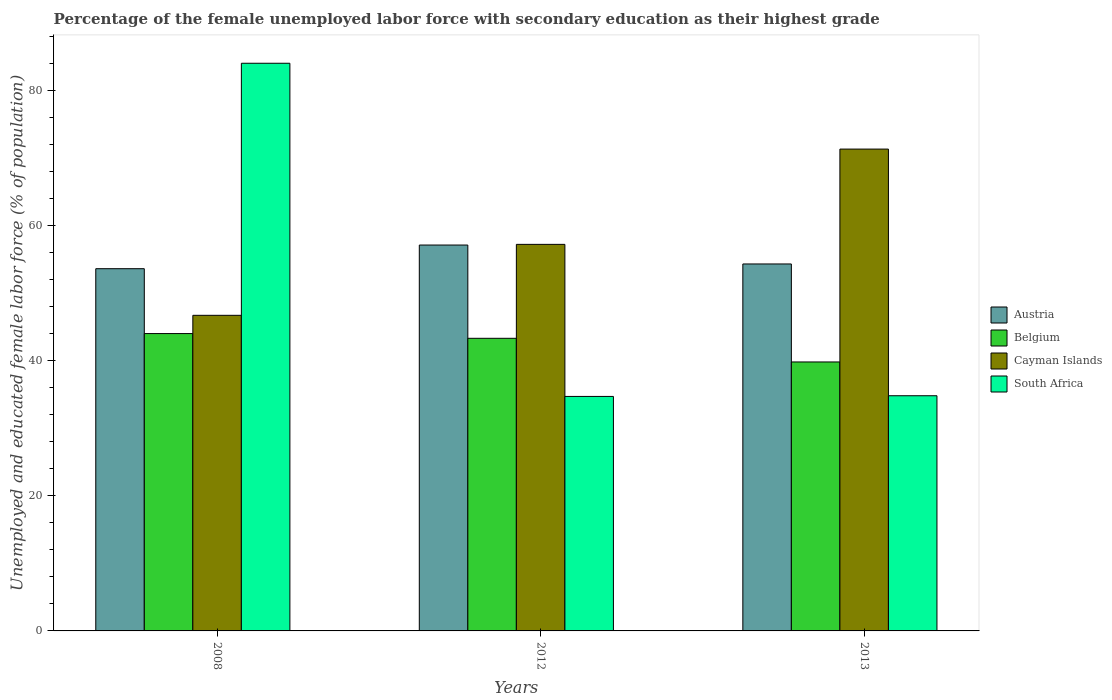How many different coloured bars are there?
Provide a short and direct response. 4. Are the number of bars per tick equal to the number of legend labels?
Provide a succinct answer. Yes. Are the number of bars on each tick of the X-axis equal?
Your answer should be very brief. Yes. How many bars are there on the 1st tick from the left?
Keep it short and to the point. 4. How many bars are there on the 3rd tick from the right?
Provide a short and direct response. 4. What is the label of the 3rd group of bars from the left?
Make the answer very short. 2013. What is the percentage of the unemployed female labor force with secondary education in Austria in 2008?
Offer a very short reply. 53.6. Across all years, what is the maximum percentage of the unemployed female labor force with secondary education in Austria?
Your response must be concise. 57.1. Across all years, what is the minimum percentage of the unemployed female labor force with secondary education in South Africa?
Keep it short and to the point. 34.7. In which year was the percentage of the unemployed female labor force with secondary education in Cayman Islands maximum?
Your answer should be compact. 2013. In which year was the percentage of the unemployed female labor force with secondary education in Austria minimum?
Ensure brevity in your answer.  2008. What is the total percentage of the unemployed female labor force with secondary education in Belgium in the graph?
Offer a terse response. 127.1. What is the difference between the percentage of the unemployed female labor force with secondary education in Austria in 2008 and that in 2013?
Your answer should be compact. -0.7. What is the difference between the percentage of the unemployed female labor force with secondary education in South Africa in 2012 and the percentage of the unemployed female labor force with secondary education in Cayman Islands in 2013?
Provide a short and direct response. -36.6. What is the average percentage of the unemployed female labor force with secondary education in Belgium per year?
Make the answer very short. 42.37. In the year 2008, what is the difference between the percentage of the unemployed female labor force with secondary education in Cayman Islands and percentage of the unemployed female labor force with secondary education in South Africa?
Give a very brief answer. -37.3. What is the ratio of the percentage of the unemployed female labor force with secondary education in South Africa in 2012 to that in 2013?
Keep it short and to the point. 1. What is the difference between the highest and the second highest percentage of the unemployed female labor force with secondary education in Austria?
Offer a terse response. 2.8. What is the difference between the highest and the lowest percentage of the unemployed female labor force with secondary education in Cayman Islands?
Provide a short and direct response. 24.6. What does the 2nd bar from the left in 2012 represents?
Offer a very short reply. Belgium. Is it the case that in every year, the sum of the percentage of the unemployed female labor force with secondary education in Belgium and percentage of the unemployed female labor force with secondary education in Cayman Islands is greater than the percentage of the unemployed female labor force with secondary education in South Africa?
Offer a very short reply. Yes. Are all the bars in the graph horizontal?
Your response must be concise. No. How many years are there in the graph?
Your answer should be very brief. 3. What is the difference between two consecutive major ticks on the Y-axis?
Offer a terse response. 20. Does the graph contain any zero values?
Provide a short and direct response. No. Where does the legend appear in the graph?
Offer a very short reply. Center right. How many legend labels are there?
Ensure brevity in your answer.  4. How are the legend labels stacked?
Your answer should be compact. Vertical. What is the title of the graph?
Provide a short and direct response. Percentage of the female unemployed labor force with secondary education as their highest grade. Does "Comoros" appear as one of the legend labels in the graph?
Offer a terse response. No. What is the label or title of the X-axis?
Your answer should be very brief. Years. What is the label or title of the Y-axis?
Provide a succinct answer. Unemployed and educated female labor force (% of population). What is the Unemployed and educated female labor force (% of population) in Austria in 2008?
Your answer should be very brief. 53.6. What is the Unemployed and educated female labor force (% of population) of Cayman Islands in 2008?
Offer a very short reply. 46.7. What is the Unemployed and educated female labor force (% of population) of South Africa in 2008?
Your answer should be very brief. 84. What is the Unemployed and educated female labor force (% of population) in Austria in 2012?
Keep it short and to the point. 57.1. What is the Unemployed and educated female labor force (% of population) of Belgium in 2012?
Ensure brevity in your answer.  43.3. What is the Unemployed and educated female labor force (% of population) in Cayman Islands in 2012?
Provide a short and direct response. 57.2. What is the Unemployed and educated female labor force (% of population) in South Africa in 2012?
Your answer should be compact. 34.7. What is the Unemployed and educated female labor force (% of population) of Austria in 2013?
Make the answer very short. 54.3. What is the Unemployed and educated female labor force (% of population) in Belgium in 2013?
Provide a succinct answer. 39.8. What is the Unemployed and educated female labor force (% of population) of Cayman Islands in 2013?
Provide a short and direct response. 71.3. What is the Unemployed and educated female labor force (% of population) of South Africa in 2013?
Your answer should be compact. 34.8. Across all years, what is the maximum Unemployed and educated female labor force (% of population) of Austria?
Provide a short and direct response. 57.1. Across all years, what is the maximum Unemployed and educated female labor force (% of population) in Cayman Islands?
Provide a short and direct response. 71.3. Across all years, what is the maximum Unemployed and educated female labor force (% of population) of South Africa?
Offer a terse response. 84. Across all years, what is the minimum Unemployed and educated female labor force (% of population) of Austria?
Offer a very short reply. 53.6. Across all years, what is the minimum Unemployed and educated female labor force (% of population) of Belgium?
Your response must be concise. 39.8. Across all years, what is the minimum Unemployed and educated female labor force (% of population) of Cayman Islands?
Offer a terse response. 46.7. Across all years, what is the minimum Unemployed and educated female labor force (% of population) of South Africa?
Make the answer very short. 34.7. What is the total Unemployed and educated female labor force (% of population) in Austria in the graph?
Make the answer very short. 165. What is the total Unemployed and educated female labor force (% of population) of Belgium in the graph?
Give a very brief answer. 127.1. What is the total Unemployed and educated female labor force (% of population) of Cayman Islands in the graph?
Your answer should be compact. 175.2. What is the total Unemployed and educated female labor force (% of population) of South Africa in the graph?
Provide a succinct answer. 153.5. What is the difference between the Unemployed and educated female labor force (% of population) of Austria in 2008 and that in 2012?
Your answer should be compact. -3.5. What is the difference between the Unemployed and educated female labor force (% of population) of Cayman Islands in 2008 and that in 2012?
Provide a succinct answer. -10.5. What is the difference between the Unemployed and educated female labor force (% of population) of South Africa in 2008 and that in 2012?
Ensure brevity in your answer.  49.3. What is the difference between the Unemployed and educated female labor force (% of population) in Cayman Islands in 2008 and that in 2013?
Your answer should be very brief. -24.6. What is the difference between the Unemployed and educated female labor force (% of population) of South Africa in 2008 and that in 2013?
Keep it short and to the point. 49.2. What is the difference between the Unemployed and educated female labor force (% of population) of Austria in 2012 and that in 2013?
Provide a short and direct response. 2.8. What is the difference between the Unemployed and educated female labor force (% of population) in Cayman Islands in 2012 and that in 2013?
Your answer should be very brief. -14.1. What is the difference between the Unemployed and educated female labor force (% of population) of South Africa in 2012 and that in 2013?
Make the answer very short. -0.1. What is the difference between the Unemployed and educated female labor force (% of population) in Austria in 2008 and the Unemployed and educated female labor force (% of population) in Belgium in 2012?
Make the answer very short. 10.3. What is the difference between the Unemployed and educated female labor force (% of population) in Austria in 2008 and the Unemployed and educated female labor force (% of population) in Cayman Islands in 2012?
Make the answer very short. -3.6. What is the difference between the Unemployed and educated female labor force (% of population) of Austria in 2008 and the Unemployed and educated female labor force (% of population) of South Africa in 2012?
Provide a short and direct response. 18.9. What is the difference between the Unemployed and educated female labor force (% of population) in Belgium in 2008 and the Unemployed and educated female labor force (% of population) in South Africa in 2012?
Offer a very short reply. 9.3. What is the difference between the Unemployed and educated female labor force (% of population) in Cayman Islands in 2008 and the Unemployed and educated female labor force (% of population) in South Africa in 2012?
Make the answer very short. 12. What is the difference between the Unemployed and educated female labor force (% of population) in Austria in 2008 and the Unemployed and educated female labor force (% of population) in Cayman Islands in 2013?
Offer a terse response. -17.7. What is the difference between the Unemployed and educated female labor force (% of population) of Austria in 2008 and the Unemployed and educated female labor force (% of population) of South Africa in 2013?
Your answer should be very brief. 18.8. What is the difference between the Unemployed and educated female labor force (% of population) in Belgium in 2008 and the Unemployed and educated female labor force (% of population) in Cayman Islands in 2013?
Your answer should be very brief. -27.3. What is the difference between the Unemployed and educated female labor force (% of population) in Austria in 2012 and the Unemployed and educated female labor force (% of population) in Belgium in 2013?
Give a very brief answer. 17.3. What is the difference between the Unemployed and educated female labor force (% of population) of Austria in 2012 and the Unemployed and educated female labor force (% of population) of South Africa in 2013?
Keep it short and to the point. 22.3. What is the difference between the Unemployed and educated female labor force (% of population) of Belgium in 2012 and the Unemployed and educated female labor force (% of population) of Cayman Islands in 2013?
Make the answer very short. -28. What is the difference between the Unemployed and educated female labor force (% of population) in Cayman Islands in 2012 and the Unemployed and educated female labor force (% of population) in South Africa in 2013?
Keep it short and to the point. 22.4. What is the average Unemployed and educated female labor force (% of population) of Austria per year?
Ensure brevity in your answer.  55. What is the average Unemployed and educated female labor force (% of population) in Belgium per year?
Ensure brevity in your answer.  42.37. What is the average Unemployed and educated female labor force (% of population) in Cayman Islands per year?
Make the answer very short. 58.4. What is the average Unemployed and educated female labor force (% of population) of South Africa per year?
Keep it short and to the point. 51.17. In the year 2008, what is the difference between the Unemployed and educated female labor force (% of population) of Austria and Unemployed and educated female labor force (% of population) of Cayman Islands?
Your answer should be very brief. 6.9. In the year 2008, what is the difference between the Unemployed and educated female labor force (% of population) of Austria and Unemployed and educated female labor force (% of population) of South Africa?
Your answer should be very brief. -30.4. In the year 2008, what is the difference between the Unemployed and educated female labor force (% of population) of Belgium and Unemployed and educated female labor force (% of population) of Cayman Islands?
Your answer should be very brief. -2.7. In the year 2008, what is the difference between the Unemployed and educated female labor force (% of population) of Belgium and Unemployed and educated female labor force (% of population) of South Africa?
Offer a terse response. -40. In the year 2008, what is the difference between the Unemployed and educated female labor force (% of population) in Cayman Islands and Unemployed and educated female labor force (% of population) in South Africa?
Make the answer very short. -37.3. In the year 2012, what is the difference between the Unemployed and educated female labor force (% of population) in Austria and Unemployed and educated female labor force (% of population) in Cayman Islands?
Your response must be concise. -0.1. In the year 2012, what is the difference between the Unemployed and educated female labor force (% of population) in Austria and Unemployed and educated female labor force (% of population) in South Africa?
Offer a terse response. 22.4. In the year 2012, what is the difference between the Unemployed and educated female labor force (% of population) of Cayman Islands and Unemployed and educated female labor force (% of population) of South Africa?
Ensure brevity in your answer.  22.5. In the year 2013, what is the difference between the Unemployed and educated female labor force (% of population) in Austria and Unemployed and educated female labor force (% of population) in Belgium?
Offer a terse response. 14.5. In the year 2013, what is the difference between the Unemployed and educated female labor force (% of population) in Austria and Unemployed and educated female labor force (% of population) in South Africa?
Ensure brevity in your answer.  19.5. In the year 2013, what is the difference between the Unemployed and educated female labor force (% of population) of Belgium and Unemployed and educated female labor force (% of population) of Cayman Islands?
Give a very brief answer. -31.5. In the year 2013, what is the difference between the Unemployed and educated female labor force (% of population) of Cayman Islands and Unemployed and educated female labor force (% of population) of South Africa?
Give a very brief answer. 36.5. What is the ratio of the Unemployed and educated female labor force (% of population) in Austria in 2008 to that in 2012?
Make the answer very short. 0.94. What is the ratio of the Unemployed and educated female labor force (% of population) in Belgium in 2008 to that in 2012?
Give a very brief answer. 1.02. What is the ratio of the Unemployed and educated female labor force (% of population) in Cayman Islands in 2008 to that in 2012?
Your answer should be very brief. 0.82. What is the ratio of the Unemployed and educated female labor force (% of population) of South Africa in 2008 to that in 2012?
Ensure brevity in your answer.  2.42. What is the ratio of the Unemployed and educated female labor force (% of population) of Austria in 2008 to that in 2013?
Offer a very short reply. 0.99. What is the ratio of the Unemployed and educated female labor force (% of population) of Belgium in 2008 to that in 2013?
Your answer should be compact. 1.11. What is the ratio of the Unemployed and educated female labor force (% of population) in Cayman Islands in 2008 to that in 2013?
Ensure brevity in your answer.  0.66. What is the ratio of the Unemployed and educated female labor force (% of population) of South Africa in 2008 to that in 2013?
Your answer should be very brief. 2.41. What is the ratio of the Unemployed and educated female labor force (% of population) in Austria in 2012 to that in 2013?
Keep it short and to the point. 1.05. What is the ratio of the Unemployed and educated female labor force (% of population) of Belgium in 2012 to that in 2013?
Provide a short and direct response. 1.09. What is the ratio of the Unemployed and educated female labor force (% of population) of Cayman Islands in 2012 to that in 2013?
Your answer should be compact. 0.8. What is the ratio of the Unemployed and educated female labor force (% of population) in South Africa in 2012 to that in 2013?
Make the answer very short. 1. What is the difference between the highest and the second highest Unemployed and educated female labor force (% of population) of Belgium?
Keep it short and to the point. 0.7. What is the difference between the highest and the second highest Unemployed and educated female labor force (% of population) of South Africa?
Provide a succinct answer. 49.2. What is the difference between the highest and the lowest Unemployed and educated female labor force (% of population) in Cayman Islands?
Make the answer very short. 24.6. What is the difference between the highest and the lowest Unemployed and educated female labor force (% of population) in South Africa?
Your answer should be very brief. 49.3. 